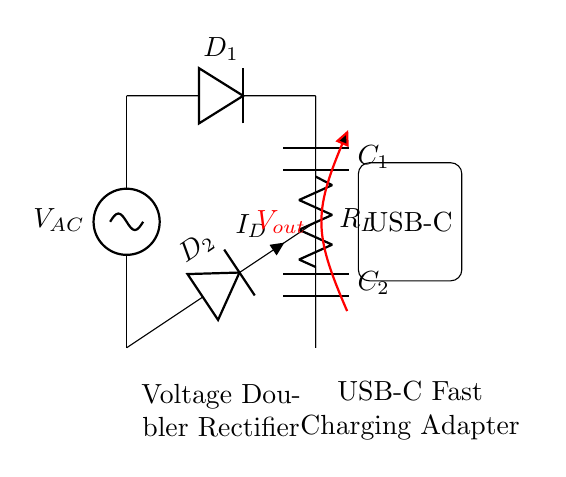What is the type of rectifier in this circuit? This circuit is a voltage doubler rectifier, as indicated by the label and the configuration of the diodes and capacitors that are designed to double the output voltage from the AC input.
Answer: Voltage doubler rectifier What is the function of diode D1? Diode D1 conducts during the positive half-cycle of the input AC voltage, allowing current to flow through to charge capacitor C1 and provide voltage to the load.
Answer: Conducts during positive half-cycle How many capacitors are present in the circuit? There are two capacitors in the circuit, labeled C1 and C2. They are used to store electrical energy and help in voltage doubling.
Answer: Two What is the output voltage symbolized as in this circuit? The output voltage is represented as V out, which is shown in red on the circuit diagram to emphasize its importance in indicating the voltage provided to the load.
Answer: V out What does capacitor C2 do in this rectifier circuit? Capacitor C2 helps to smooth out the voltage and combine with the charge from capacitor C1, ultimately contributing to the voltage doubling effect across the load.
Answer: Contributes to voltage doubling What is the role of the load resistor R_L? The load resistor R_L represents the component that uses the output voltage in the circuit, making it a crucial part for understanding how current is delivered to an external device.
Answer: It represents the load What happens to the current I_D during the negative half-cycle of the AC input? During the negative half-cycle, diode D2 conducts while D1 is reverse-biased, allowing current I_D to flow to charge capacitor C2 and maintain the output voltage stability.
Answer: Current flows through D2 